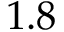Convert formula to latex. <formula><loc_0><loc_0><loc_500><loc_500>1 . 8</formula> 